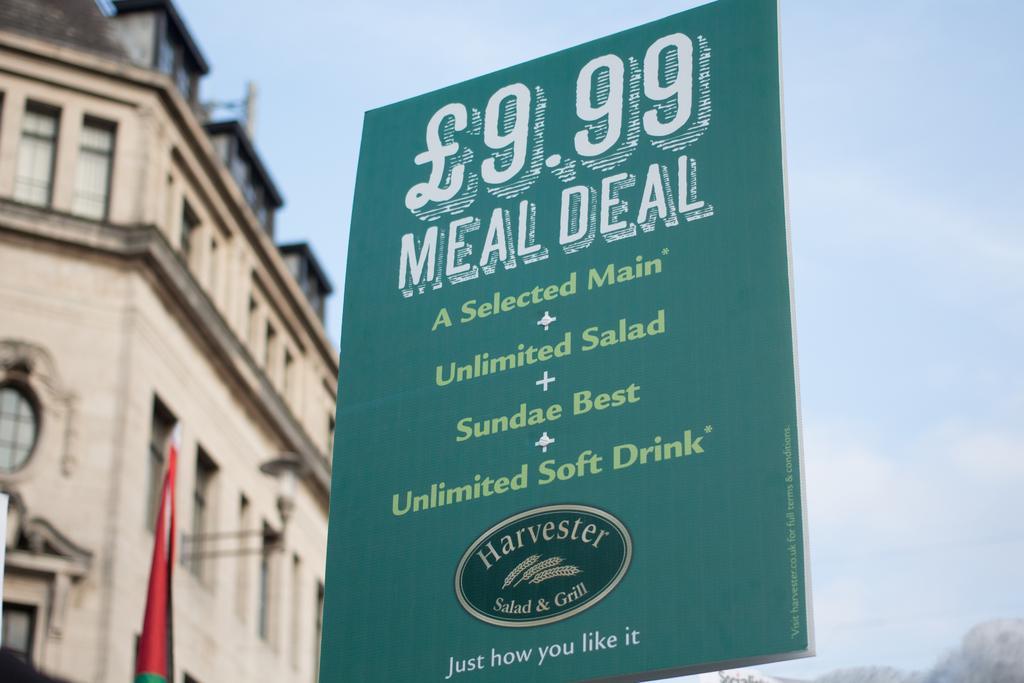Describe this image in one or two sentences. In the middle of the image we can see a banner. Behind the banner there are some clouds in the sky. On the left side of the image there are some buildings. 